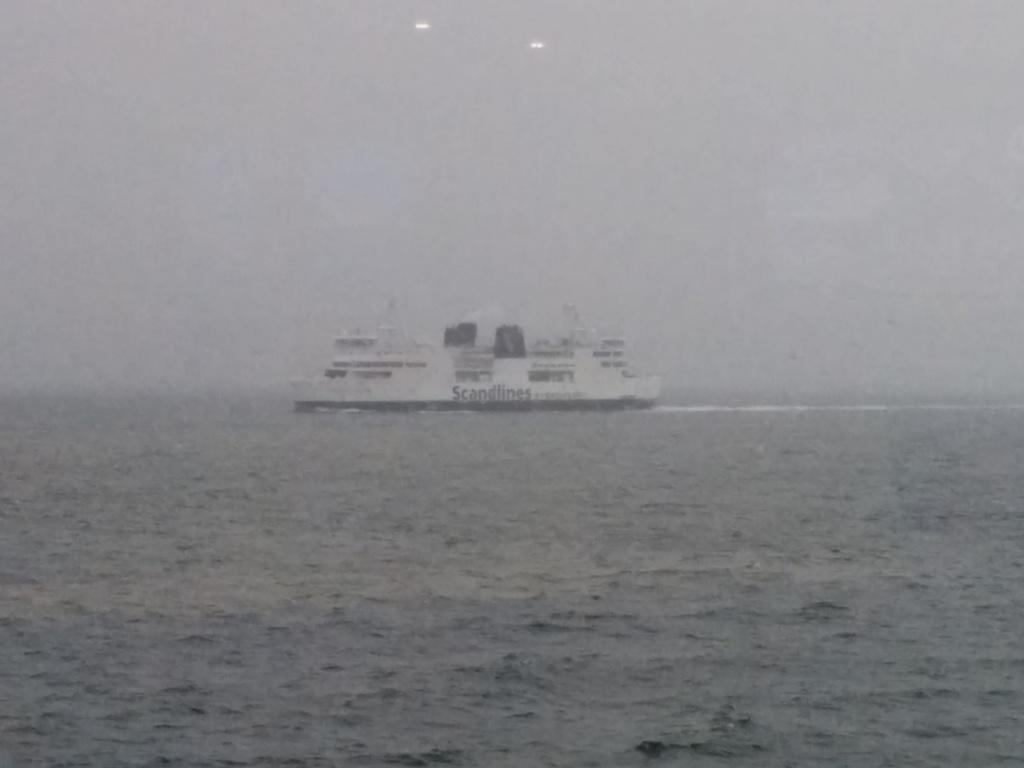What is the main subject of the image? The main subject of the image is a ship. Where is the ship located? The ship is on water. What can be seen on the ship? The ship has some text on it. What is visible in the background of the image? The sky is visible in the image. Can you tell me how many buns are on the sofa in the image? There is no sofa or buns present in the image; it features a ship on water. Is the ship driving in the image? Ships do not drive; they sail or navigate on water. The image shows a stationary ship on water. 